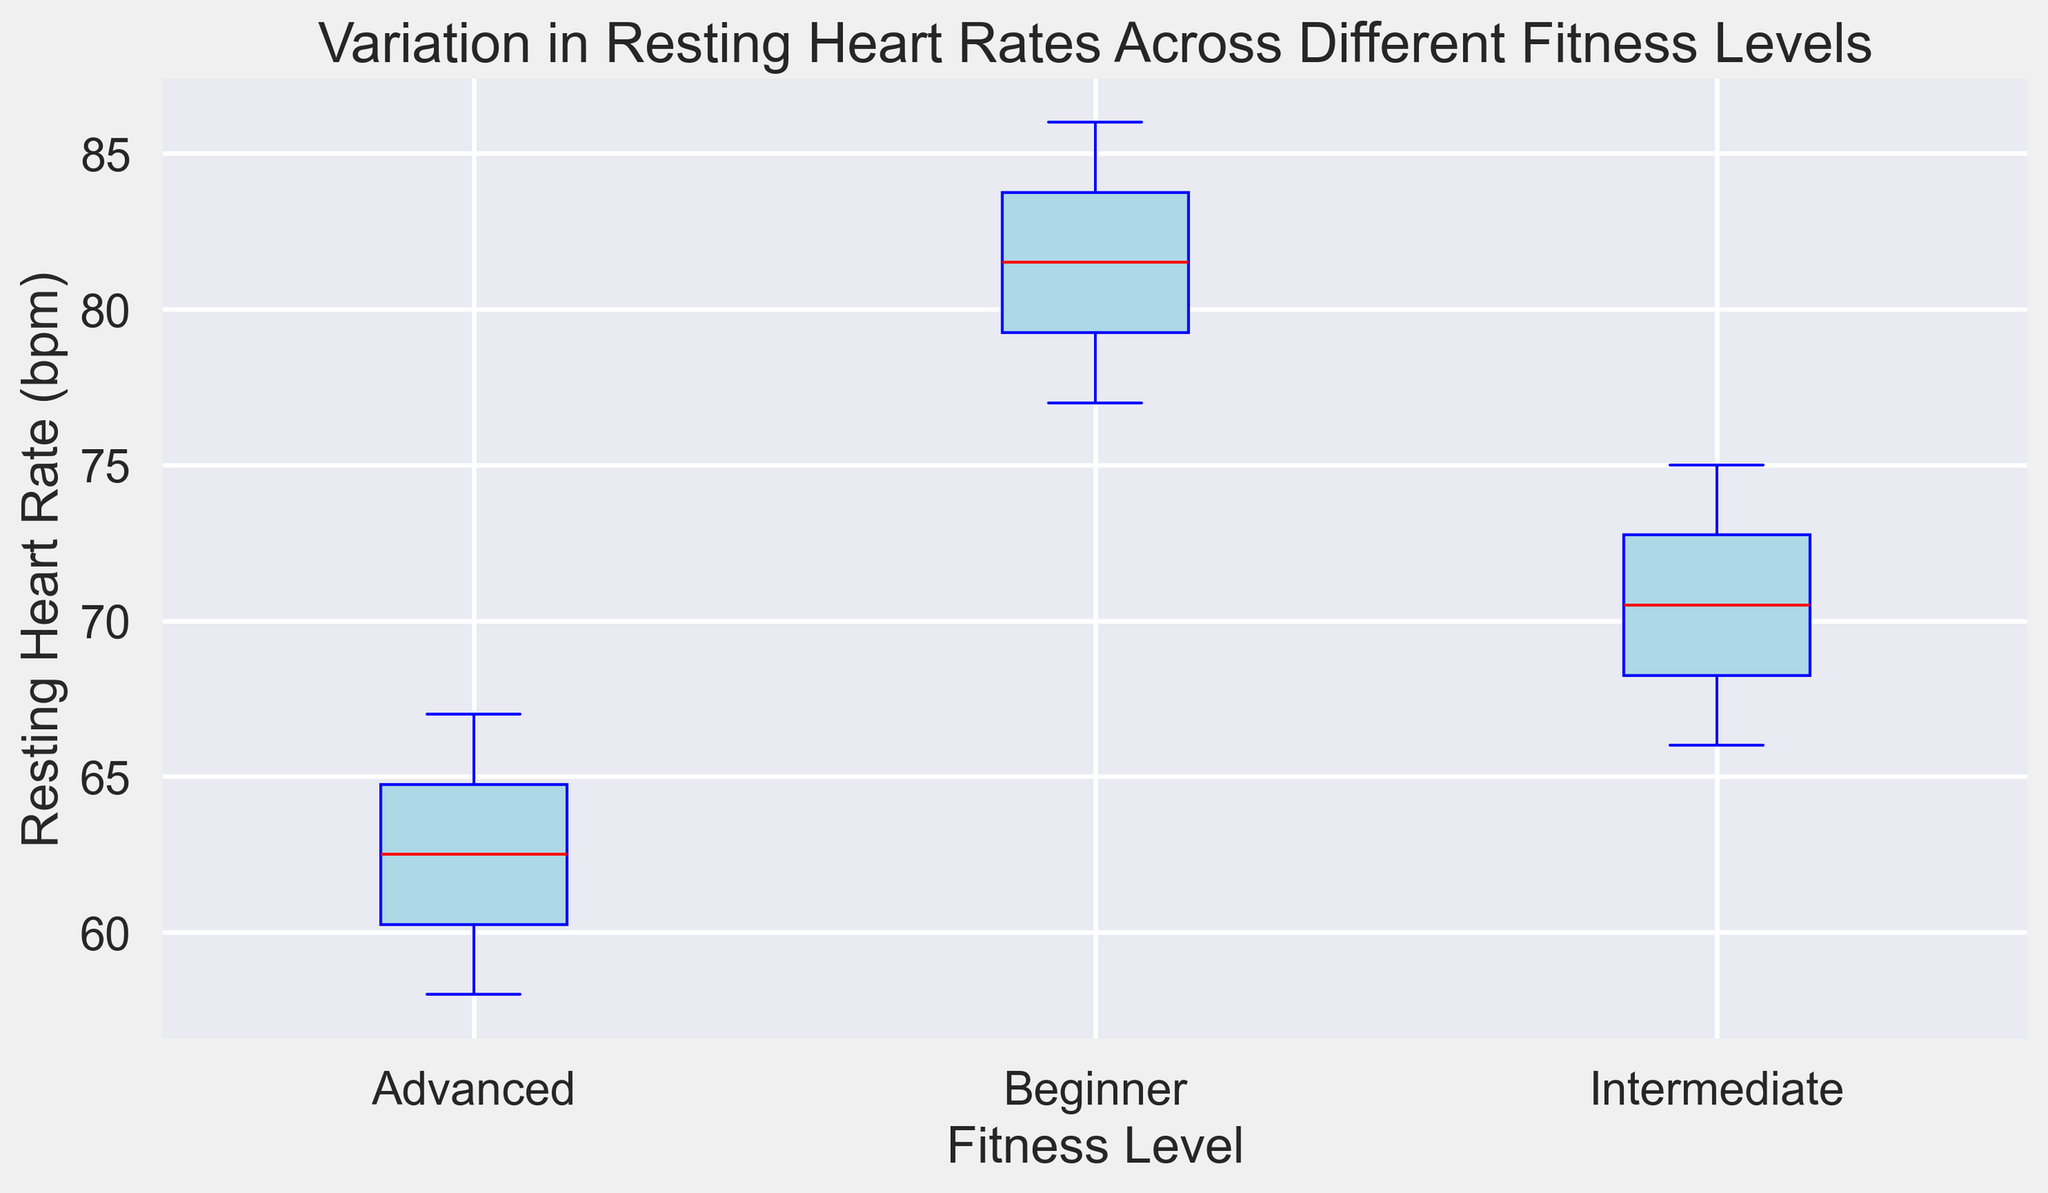Which fitness level has the highest median resting heart rate? The median resting heart rate can be identified by looking at the red line inside each box. The Beginner group has the highest median resting heart rate as its red line is higher than the others.
Answer: Beginner What is the difference in the median resting heart rates between the Beginner and Advanced fitness levels? To find the difference, subtract the median value of the Advanced group from the median value of the Beginner group. If the Beginner median is 82 and the Advanced median is 62, the difference is 82 - 62.
Answer: 20 bpm Which fitness level shows the widest range in resting heart rates? The range can be determined by looking at the distance between the top and bottom lines (whiskers) of each boxplot. The Beginner fitness level has the widest range.
Answer: Beginner Are there any outliers in the Intermediate fitness level's resting heart rates? Outliers are indicated by green markers outside the whiskers of the boxplot. Since there are no green markers for the Intermediate fitness level, there are no outliers.
Answer: No Which fitness level has the lowest minimum resting heart rate? The minimum resting heart rate is indicated by the bottom whisker of the boxplot. The Advanced fitness level has the lowest minimum resting heart rate.
Answer: Advanced By how much does the maximum resting heart rate of the Beginner group exceed that of the Advanced group? To find this, subtract the maximum value of the Advanced group from the maximum value of the Beginner group. If the Beginner maximum is 86 and the Advanced maximum is 67, the difference is 86 - 67.
Answer: 19 bpm What is the interquartile range (IQR) for the Intermediate fitness level's resting heart rates? The IQR is the difference between the third quartile (top edge of the box) and the first quartile (bottom edge of the box). For the Intermediate group, the IQR is 74 - 68.
Answer: 6 bpm Which fitness level shows the least variation in resting heart rates? Variation can be judged by the height of the box and whiskers. The Advanced fitness level shows the least variation as its box and whiskers are shortest.
Answer: Advanced Is there any overlap between the resting heart rates of the Beginner and Intermediate fitness levels? Overlap can be observed by checking the range of resting heart rates between the two groups. Both groups have some overlapping values as the whiskers intersect.
Answer: Yes What color represents the median line in the boxplots? The color of the median line can be identified from the visual. The median line in the boxplots is colored red.
Answer: Red 